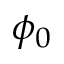Convert formula to latex. <formula><loc_0><loc_0><loc_500><loc_500>\phi _ { 0 }</formula> 